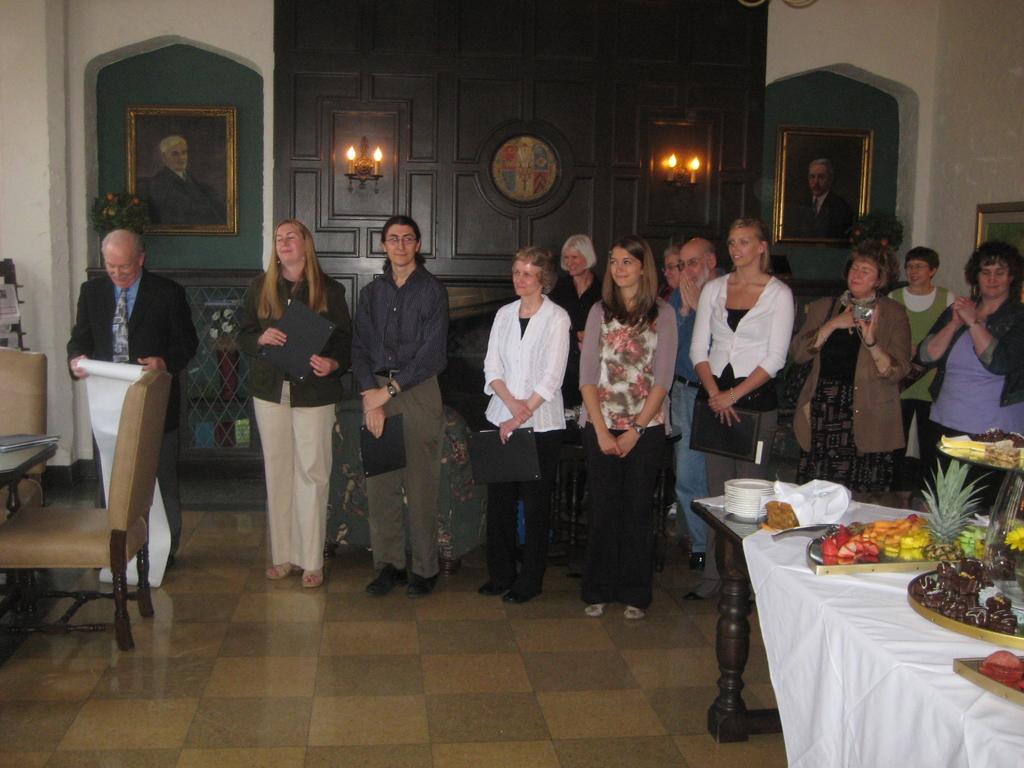Please provide a concise description of this image. In the picture there are few men and women stood in the back side on the floor, on right side there is a table with fruits on it,this seems to be in a home and on background there is a door,on either sides there are lights with photo frames. 